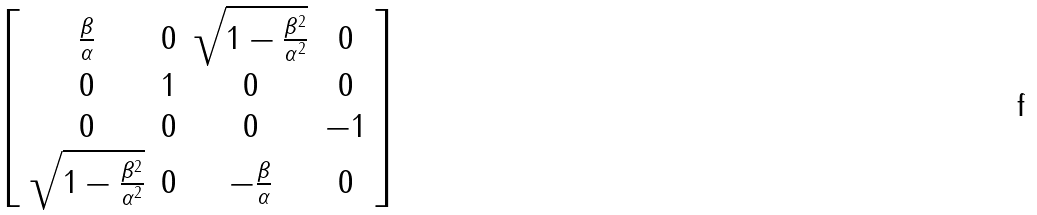Convert formula to latex. <formula><loc_0><loc_0><loc_500><loc_500>\left [ \begin{array} { c c c c } \frac { \beta } { \alpha } & 0 & \sqrt { 1 - \frac { \beta ^ { 2 } } { \alpha ^ { 2 } } } & 0 \\ 0 & 1 & 0 & 0 \\ 0 & 0 & 0 & - 1 \\ \sqrt { 1 - \frac { \beta ^ { 2 } } { \alpha ^ { 2 } } } & 0 & - \frac { \beta } { \alpha } & 0 \end{array} \right ]</formula> 